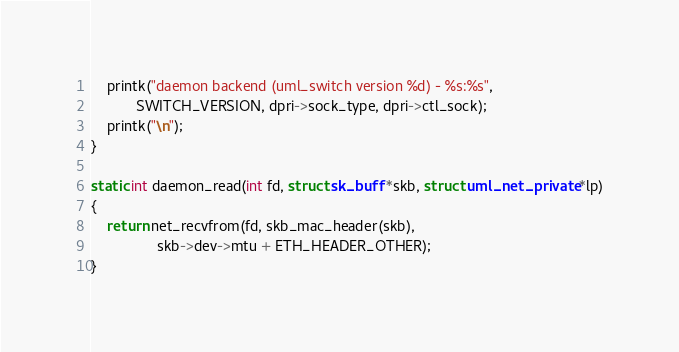Convert code to text. <code><loc_0><loc_0><loc_500><loc_500><_C_>	printk("daemon backend (uml_switch version %d) - %s:%s",
	       SWITCH_VERSION, dpri->sock_type, dpri->ctl_sock);
	printk("\n");
}

static int daemon_read(int fd, struct sk_buff *skb, struct uml_net_private *lp)
{
	return net_recvfrom(fd, skb_mac_header(skb),
			    skb->dev->mtu + ETH_HEADER_OTHER);
}
</code> 